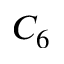Convert formula to latex. <formula><loc_0><loc_0><loc_500><loc_500>C _ { 6 }</formula> 